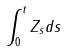<formula> <loc_0><loc_0><loc_500><loc_500>\int _ { 0 } ^ { t } Z _ { s } d s</formula> 